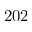Convert formula to latex. <formula><loc_0><loc_0><loc_500><loc_500>2 0 2</formula> 